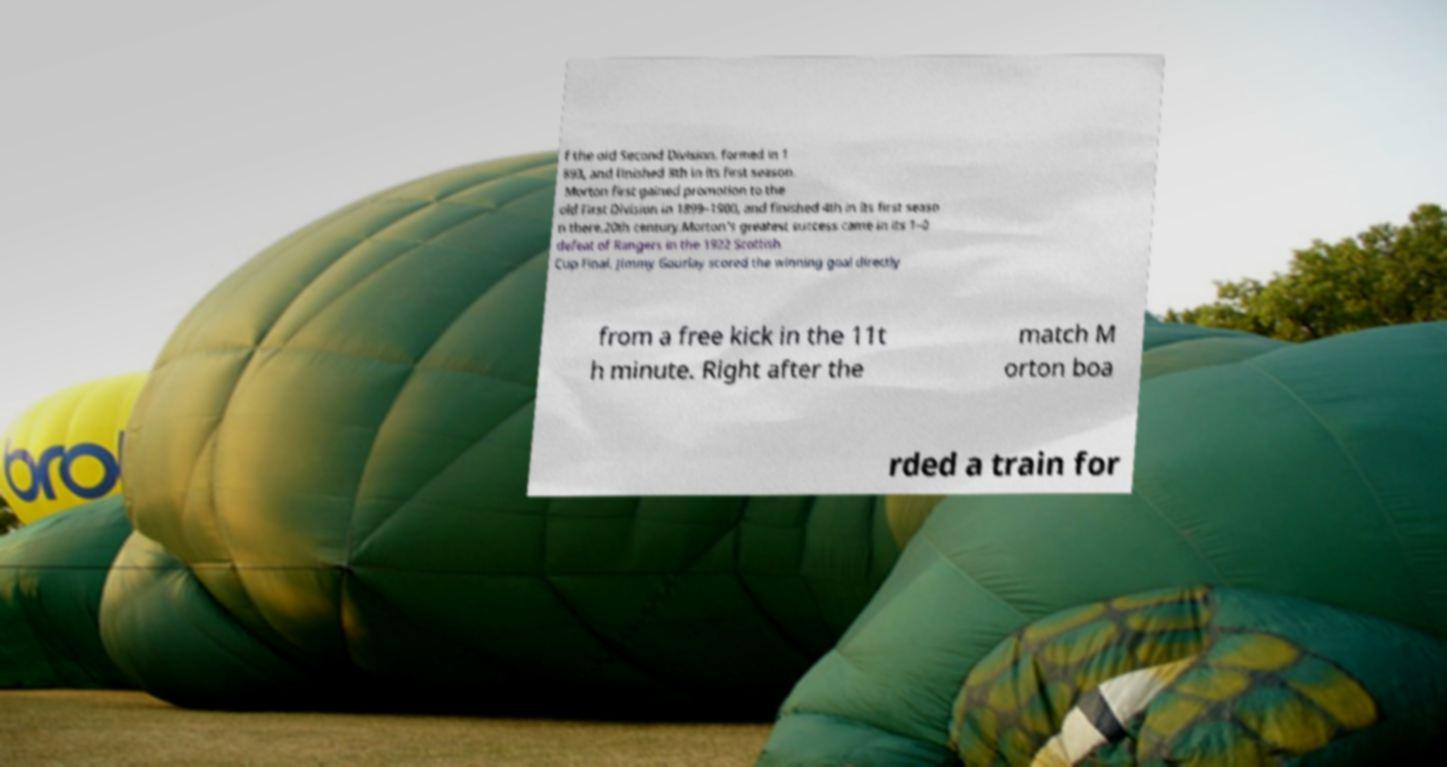For documentation purposes, I need the text within this image transcribed. Could you provide that? f the old Second Division, formed in 1 893, and finished 8th in its first season. Morton first gained promotion to the old First Division in 1899–1900, and finished 4th in its first seaso n there.20th century.Morton's greatest success came in its 1–0 defeat of Rangers in the 1922 Scottish Cup Final. Jimmy Gourlay scored the winning goal directly from a free kick in the 11t h minute. Right after the match M orton boa rded a train for 